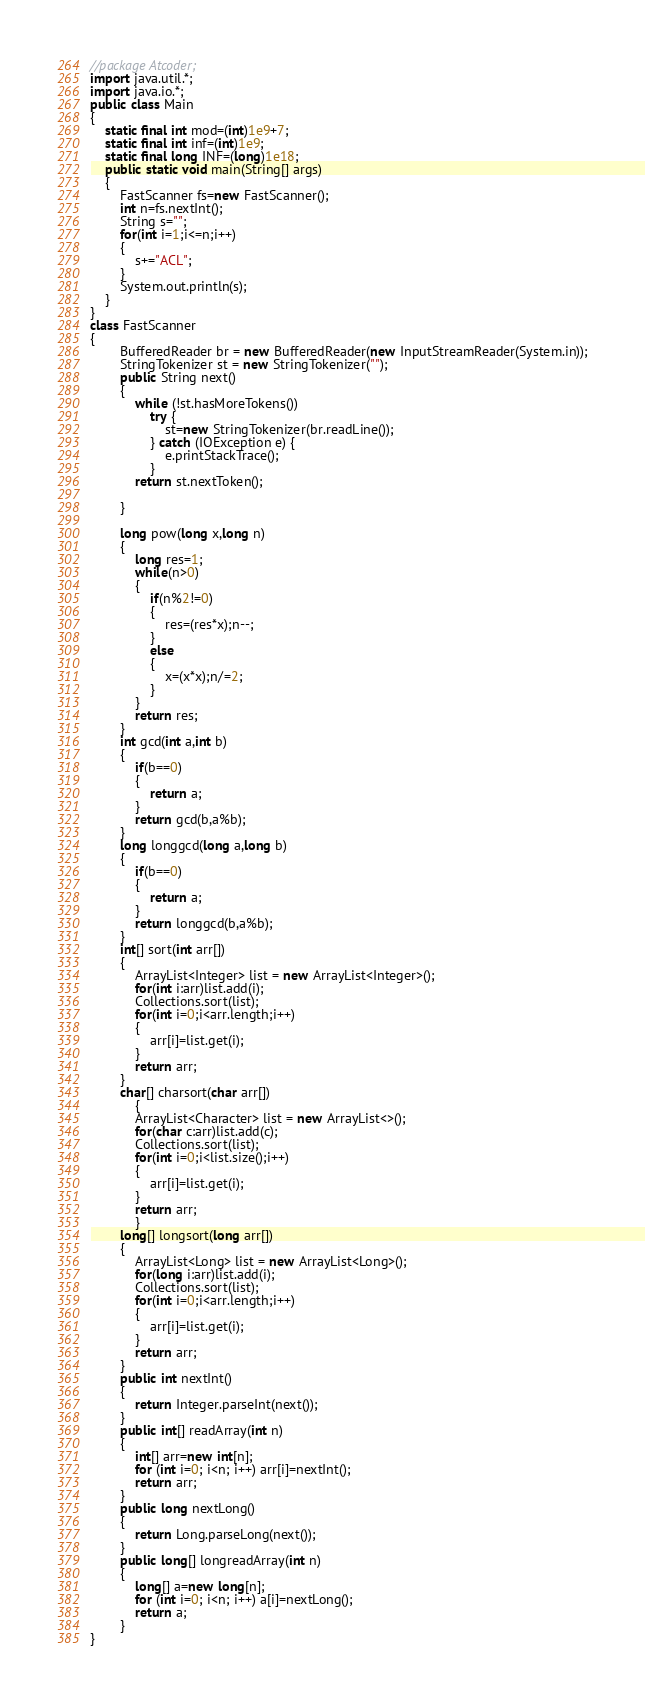Convert code to text. <code><loc_0><loc_0><loc_500><loc_500><_Java_>//package Atcoder;
import java.util.*;
import java.io.*;
public class Main
{
	static final int mod=(int)1e9+7;
	static final int inf=(int)1e9;
	static final long INF=(long)1e18;
	public static void main(String[] args)
	{
		FastScanner fs=new FastScanner();
		int n=fs.nextInt();
		String s="";
		for(int i=1;i<=n;i++)
		{
			s+="ACL";
		}
		System.out.println(s);
	}
}
class FastScanner 
{
		BufferedReader br = new BufferedReader(new InputStreamReader(System.in));
		StringTokenizer st = new StringTokenizer("");
		public String next() 
		{
			while (!st.hasMoreTokens())
				try {
					st=new StringTokenizer(br.readLine());
				} catch (IOException e) {
					e.printStackTrace();
				}
			return st.nextToken();
			
		}
		
		long pow(long x,long n)
		{
			long res=1;
			while(n>0)
			{
			   	if(n%2!=0)
			   	{
			   		res=(res*x);n--;
			   	}
			   	else
			   	{
			   		x=(x*x);n/=2;
			   	}
			}
			return res;
		}
		int gcd(int a,int b)
		{
			if(b==0)
			{
				return a;
			}
			return gcd(b,a%b);
		}
		long longgcd(long a,long b)
		{
			if(b==0)
			{
				return a;
			}
			return longgcd(b,a%b);
		}
		int[] sort(int arr[])
		{
			ArrayList<Integer> list = new ArrayList<Integer>();
			for(int i:arr)list.add(i);
			Collections.sort(list);
			for(int i=0;i<arr.length;i++)
			{
				arr[i]=list.get(i);
			}
			return arr;
		}
		char[] charsort(char arr[])
	        {
	    	ArrayList<Character> list = new ArrayList<>();
	    	for(char c:arr)list.add(c);
	    	Collections.sort(list);
	    	for(int i=0;i<list.size();i++)
	    	{
	    		arr[i]=list.get(i);
	    	}
	    	return arr;
	        }
		long[] longsort(long arr[])
		{
			ArrayList<Long> list = new ArrayList<Long>();
			for(long i:arr)list.add(i);
			Collections.sort(list);
			for(int i=0;i<arr.length;i++)
			{
				arr[i]=list.get(i);
			}
			return arr;
		}
		public int nextInt() 
		{
			return Integer.parseInt(next());
		}
		public int[] readArray(int n)
		{
			int[] arr=new int[n];
			for (int i=0; i<n; i++) arr[i]=nextInt();
			return arr;
		}	
		public long nextLong()
		{
			return Long.parseLong(next());
		}
		public long[] longreadArray(int n) 
		{
			long[] a=new long[n];
			for (int i=0; i<n; i++) a[i]=nextLong();
			return a;
		}
}</code> 